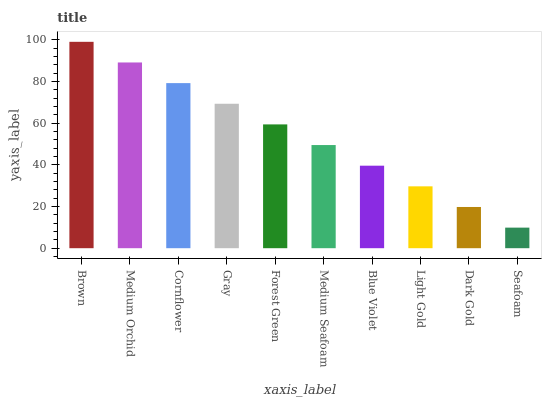Is Seafoam the minimum?
Answer yes or no. Yes. Is Brown the maximum?
Answer yes or no. Yes. Is Medium Orchid the minimum?
Answer yes or no. No. Is Medium Orchid the maximum?
Answer yes or no. No. Is Brown greater than Medium Orchid?
Answer yes or no. Yes. Is Medium Orchid less than Brown?
Answer yes or no. Yes. Is Medium Orchid greater than Brown?
Answer yes or no. No. Is Brown less than Medium Orchid?
Answer yes or no. No. Is Forest Green the high median?
Answer yes or no. Yes. Is Medium Seafoam the low median?
Answer yes or no. Yes. Is Medium Orchid the high median?
Answer yes or no. No. Is Medium Orchid the low median?
Answer yes or no. No. 